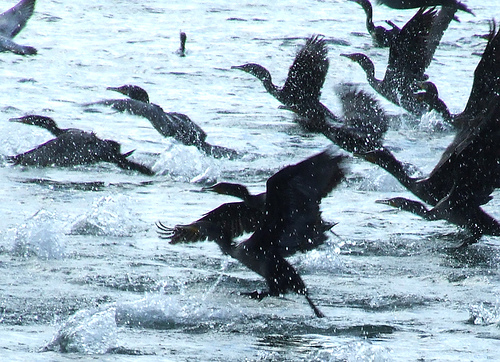Please provide the bounding box coordinate of the region this sentence describes: Birds feet in the water. The bounding box coordinates for the region where 'bird's feet in the water' are visible are [0.46, 0.68, 0.62, 0.77]. This area focuses on the bird's feet as they make contact with the water surface. 